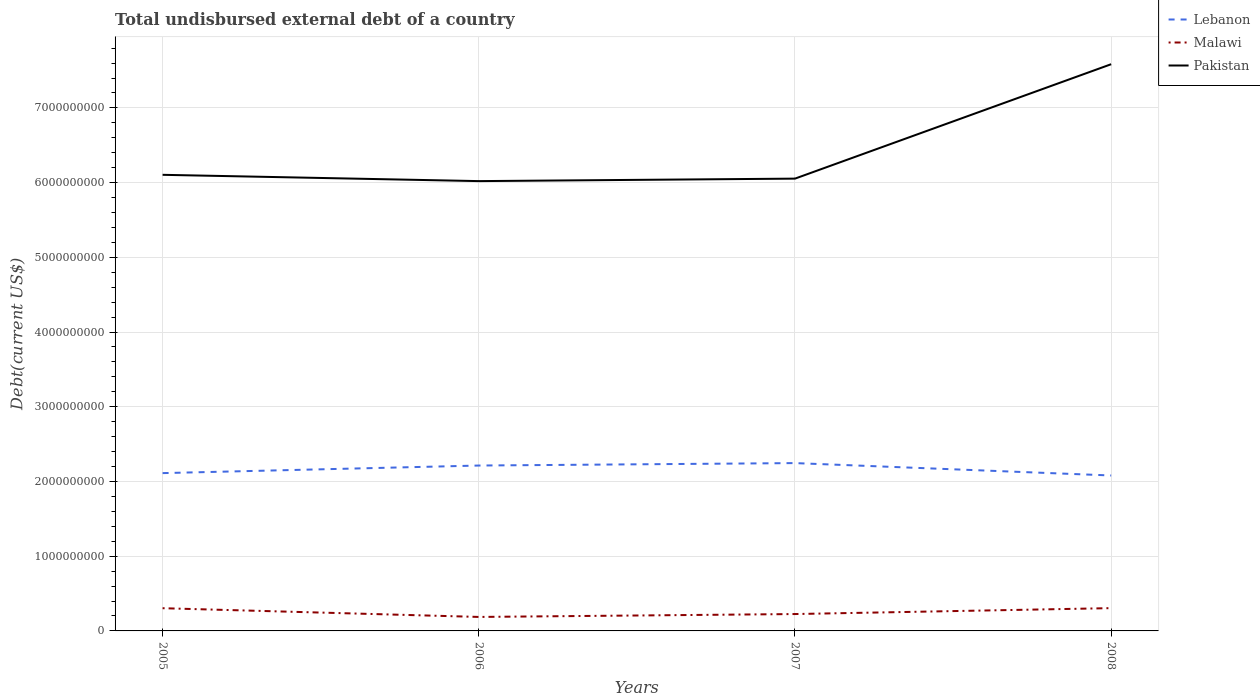Does the line corresponding to Lebanon intersect with the line corresponding to Pakistan?
Keep it short and to the point. No. Is the number of lines equal to the number of legend labels?
Offer a very short reply. Yes. Across all years, what is the maximum total undisbursed external debt in Pakistan?
Give a very brief answer. 6.02e+09. What is the total total undisbursed external debt in Pakistan in the graph?
Your answer should be compact. 8.43e+07. What is the difference between the highest and the second highest total undisbursed external debt in Lebanon?
Offer a terse response. 1.66e+08. What is the difference between the highest and the lowest total undisbursed external debt in Pakistan?
Your answer should be compact. 1. How many lines are there?
Keep it short and to the point. 3. What is the difference between two consecutive major ticks on the Y-axis?
Your answer should be very brief. 1.00e+09. How are the legend labels stacked?
Make the answer very short. Vertical. What is the title of the graph?
Give a very brief answer. Total undisbursed external debt of a country. Does "Turks and Caicos Islands" appear as one of the legend labels in the graph?
Offer a terse response. No. What is the label or title of the X-axis?
Your answer should be very brief. Years. What is the label or title of the Y-axis?
Give a very brief answer. Debt(current US$). What is the Debt(current US$) of Lebanon in 2005?
Your response must be concise. 2.11e+09. What is the Debt(current US$) in Malawi in 2005?
Offer a terse response. 3.04e+08. What is the Debt(current US$) in Pakistan in 2005?
Offer a terse response. 6.10e+09. What is the Debt(current US$) of Lebanon in 2006?
Your answer should be very brief. 2.21e+09. What is the Debt(current US$) in Malawi in 2006?
Give a very brief answer. 1.87e+08. What is the Debt(current US$) in Pakistan in 2006?
Offer a terse response. 6.02e+09. What is the Debt(current US$) of Lebanon in 2007?
Keep it short and to the point. 2.25e+09. What is the Debt(current US$) in Malawi in 2007?
Your answer should be compact. 2.26e+08. What is the Debt(current US$) of Pakistan in 2007?
Make the answer very short. 6.05e+09. What is the Debt(current US$) in Lebanon in 2008?
Keep it short and to the point. 2.08e+09. What is the Debt(current US$) of Malawi in 2008?
Ensure brevity in your answer.  3.05e+08. What is the Debt(current US$) in Pakistan in 2008?
Ensure brevity in your answer.  7.58e+09. Across all years, what is the maximum Debt(current US$) of Lebanon?
Provide a short and direct response. 2.25e+09. Across all years, what is the maximum Debt(current US$) of Malawi?
Your response must be concise. 3.05e+08. Across all years, what is the maximum Debt(current US$) in Pakistan?
Make the answer very short. 7.58e+09. Across all years, what is the minimum Debt(current US$) in Lebanon?
Offer a terse response. 2.08e+09. Across all years, what is the minimum Debt(current US$) in Malawi?
Your response must be concise. 1.87e+08. Across all years, what is the minimum Debt(current US$) of Pakistan?
Provide a succinct answer. 6.02e+09. What is the total Debt(current US$) of Lebanon in the graph?
Keep it short and to the point. 8.65e+09. What is the total Debt(current US$) of Malawi in the graph?
Make the answer very short. 1.02e+09. What is the total Debt(current US$) in Pakistan in the graph?
Your answer should be very brief. 2.58e+1. What is the difference between the Debt(current US$) in Lebanon in 2005 and that in 2006?
Give a very brief answer. -1.01e+08. What is the difference between the Debt(current US$) of Malawi in 2005 and that in 2006?
Offer a terse response. 1.17e+08. What is the difference between the Debt(current US$) of Pakistan in 2005 and that in 2006?
Provide a short and direct response. 8.43e+07. What is the difference between the Debt(current US$) of Lebanon in 2005 and that in 2007?
Offer a terse response. -1.34e+08. What is the difference between the Debt(current US$) in Malawi in 2005 and that in 2007?
Give a very brief answer. 7.81e+07. What is the difference between the Debt(current US$) of Pakistan in 2005 and that in 2007?
Make the answer very short. 5.10e+07. What is the difference between the Debt(current US$) in Lebanon in 2005 and that in 2008?
Provide a succinct answer. 3.19e+07. What is the difference between the Debt(current US$) in Malawi in 2005 and that in 2008?
Offer a very short reply. -9.46e+05. What is the difference between the Debt(current US$) of Pakistan in 2005 and that in 2008?
Provide a succinct answer. -1.48e+09. What is the difference between the Debt(current US$) in Lebanon in 2006 and that in 2007?
Your response must be concise. -3.26e+07. What is the difference between the Debt(current US$) in Malawi in 2006 and that in 2007?
Keep it short and to the point. -3.88e+07. What is the difference between the Debt(current US$) in Pakistan in 2006 and that in 2007?
Give a very brief answer. -3.33e+07. What is the difference between the Debt(current US$) in Lebanon in 2006 and that in 2008?
Offer a terse response. 1.33e+08. What is the difference between the Debt(current US$) of Malawi in 2006 and that in 2008?
Keep it short and to the point. -1.18e+08. What is the difference between the Debt(current US$) in Pakistan in 2006 and that in 2008?
Provide a succinct answer. -1.56e+09. What is the difference between the Debt(current US$) of Lebanon in 2007 and that in 2008?
Offer a terse response. 1.66e+08. What is the difference between the Debt(current US$) of Malawi in 2007 and that in 2008?
Your answer should be very brief. -7.91e+07. What is the difference between the Debt(current US$) in Pakistan in 2007 and that in 2008?
Make the answer very short. -1.53e+09. What is the difference between the Debt(current US$) in Lebanon in 2005 and the Debt(current US$) in Malawi in 2006?
Offer a very short reply. 1.92e+09. What is the difference between the Debt(current US$) of Lebanon in 2005 and the Debt(current US$) of Pakistan in 2006?
Keep it short and to the point. -3.91e+09. What is the difference between the Debt(current US$) of Malawi in 2005 and the Debt(current US$) of Pakistan in 2006?
Your answer should be compact. -5.72e+09. What is the difference between the Debt(current US$) of Lebanon in 2005 and the Debt(current US$) of Malawi in 2007?
Provide a short and direct response. 1.89e+09. What is the difference between the Debt(current US$) in Lebanon in 2005 and the Debt(current US$) in Pakistan in 2007?
Ensure brevity in your answer.  -3.94e+09. What is the difference between the Debt(current US$) in Malawi in 2005 and the Debt(current US$) in Pakistan in 2007?
Your response must be concise. -5.75e+09. What is the difference between the Debt(current US$) of Lebanon in 2005 and the Debt(current US$) of Malawi in 2008?
Your response must be concise. 1.81e+09. What is the difference between the Debt(current US$) in Lebanon in 2005 and the Debt(current US$) in Pakistan in 2008?
Offer a terse response. -5.47e+09. What is the difference between the Debt(current US$) in Malawi in 2005 and the Debt(current US$) in Pakistan in 2008?
Your response must be concise. -7.28e+09. What is the difference between the Debt(current US$) of Lebanon in 2006 and the Debt(current US$) of Malawi in 2007?
Provide a short and direct response. 1.99e+09. What is the difference between the Debt(current US$) of Lebanon in 2006 and the Debt(current US$) of Pakistan in 2007?
Your answer should be compact. -3.84e+09. What is the difference between the Debt(current US$) in Malawi in 2006 and the Debt(current US$) in Pakistan in 2007?
Offer a very short reply. -5.87e+09. What is the difference between the Debt(current US$) of Lebanon in 2006 and the Debt(current US$) of Malawi in 2008?
Your response must be concise. 1.91e+09. What is the difference between the Debt(current US$) of Lebanon in 2006 and the Debt(current US$) of Pakistan in 2008?
Give a very brief answer. -5.37e+09. What is the difference between the Debt(current US$) of Malawi in 2006 and the Debt(current US$) of Pakistan in 2008?
Offer a very short reply. -7.40e+09. What is the difference between the Debt(current US$) of Lebanon in 2007 and the Debt(current US$) of Malawi in 2008?
Your answer should be very brief. 1.94e+09. What is the difference between the Debt(current US$) in Lebanon in 2007 and the Debt(current US$) in Pakistan in 2008?
Your answer should be very brief. -5.34e+09. What is the difference between the Debt(current US$) in Malawi in 2007 and the Debt(current US$) in Pakistan in 2008?
Make the answer very short. -7.36e+09. What is the average Debt(current US$) in Lebanon per year?
Keep it short and to the point. 2.16e+09. What is the average Debt(current US$) in Malawi per year?
Offer a very short reply. 2.56e+08. What is the average Debt(current US$) in Pakistan per year?
Keep it short and to the point. 6.44e+09. In the year 2005, what is the difference between the Debt(current US$) of Lebanon and Debt(current US$) of Malawi?
Your response must be concise. 1.81e+09. In the year 2005, what is the difference between the Debt(current US$) in Lebanon and Debt(current US$) in Pakistan?
Ensure brevity in your answer.  -3.99e+09. In the year 2005, what is the difference between the Debt(current US$) in Malawi and Debt(current US$) in Pakistan?
Your answer should be very brief. -5.80e+09. In the year 2006, what is the difference between the Debt(current US$) in Lebanon and Debt(current US$) in Malawi?
Your answer should be very brief. 2.03e+09. In the year 2006, what is the difference between the Debt(current US$) in Lebanon and Debt(current US$) in Pakistan?
Keep it short and to the point. -3.81e+09. In the year 2006, what is the difference between the Debt(current US$) of Malawi and Debt(current US$) of Pakistan?
Give a very brief answer. -5.83e+09. In the year 2007, what is the difference between the Debt(current US$) of Lebanon and Debt(current US$) of Malawi?
Make the answer very short. 2.02e+09. In the year 2007, what is the difference between the Debt(current US$) of Lebanon and Debt(current US$) of Pakistan?
Provide a short and direct response. -3.81e+09. In the year 2007, what is the difference between the Debt(current US$) in Malawi and Debt(current US$) in Pakistan?
Offer a terse response. -5.83e+09. In the year 2008, what is the difference between the Debt(current US$) of Lebanon and Debt(current US$) of Malawi?
Your response must be concise. 1.78e+09. In the year 2008, what is the difference between the Debt(current US$) in Lebanon and Debt(current US$) in Pakistan?
Give a very brief answer. -5.50e+09. In the year 2008, what is the difference between the Debt(current US$) of Malawi and Debt(current US$) of Pakistan?
Your answer should be compact. -7.28e+09. What is the ratio of the Debt(current US$) in Lebanon in 2005 to that in 2006?
Offer a very short reply. 0.95. What is the ratio of the Debt(current US$) in Malawi in 2005 to that in 2006?
Your response must be concise. 1.62. What is the ratio of the Debt(current US$) of Pakistan in 2005 to that in 2006?
Offer a very short reply. 1.01. What is the ratio of the Debt(current US$) of Lebanon in 2005 to that in 2007?
Your answer should be compact. 0.94. What is the ratio of the Debt(current US$) of Malawi in 2005 to that in 2007?
Your answer should be very brief. 1.35. What is the ratio of the Debt(current US$) of Pakistan in 2005 to that in 2007?
Ensure brevity in your answer.  1.01. What is the ratio of the Debt(current US$) of Lebanon in 2005 to that in 2008?
Offer a very short reply. 1.02. What is the ratio of the Debt(current US$) of Pakistan in 2005 to that in 2008?
Keep it short and to the point. 0.8. What is the ratio of the Debt(current US$) of Lebanon in 2006 to that in 2007?
Offer a terse response. 0.99. What is the ratio of the Debt(current US$) of Malawi in 2006 to that in 2007?
Give a very brief answer. 0.83. What is the ratio of the Debt(current US$) of Lebanon in 2006 to that in 2008?
Your answer should be very brief. 1.06. What is the ratio of the Debt(current US$) of Malawi in 2006 to that in 2008?
Offer a very short reply. 0.61. What is the ratio of the Debt(current US$) of Pakistan in 2006 to that in 2008?
Offer a terse response. 0.79. What is the ratio of the Debt(current US$) of Lebanon in 2007 to that in 2008?
Keep it short and to the point. 1.08. What is the ratio of the Debt(current US$) of Malawi in 2007 to that in 2008?
Make the answer very short. 0.74. What is the ratio of the Debt(current US$) of Pakistan in 2007 to that in 2008?
Your answer should be very brief. 0.8. What is the difference between the highest and the second highest Debt(current US$) in Lebanon?
Provide a succinct answer. 3.26e+07. What is the difference between the highest and the second highest Debt(current US$) in Malawi?
Your answer should be compact. 9.46e+05. What is the difference between the highest and the second highest Debt(current US$) in Pakistan?
Provide a short and direct response. 1.48e+09. What is the difference between the highest and the lowest Debt(current US$) of Lebanon?
Your response must be concise. 1.66e+08. What is the difference between the highest and the lowest Debt(current US$) of Malawi?
Provide a short and direct response. 1.18e+08. What is the difference between the highest and the lowest Debt(current US$) in Pakistan?
Give a very brief answer. 1.56e+09. 